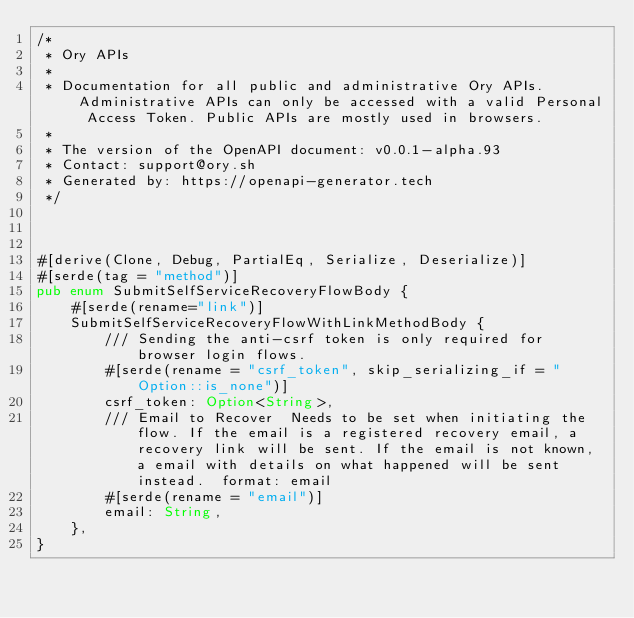Convert code to text. <code><loc_0><loc_0><loc_500><loc_500><_Rust_>/*
 * Ory APIs
 *
 * Documentation for all public and administrative Ory APIs. Administrative APIs can only be accessed with a valid Personal Access Token. Public APIs are mostly used in browsers. 
 *
 * The version of the OpenAPI document: v0.0.1-alpha.93
 * Contact: support@ory.sh
 * Generated by: https://openapi-generator.tech
 */



#[derive(Clone, Debug, PartialEq, Serialize, Deserialize)]
#[serde(tag = "method")]
pub enum SubmitSelfServiceRecoveryFlowBody {
    #[serde(rename="link")]
    SubmitSelfServiceRecoveryFlowWithLinkMethodBody {
        /// Sending the anti-csrf token is only required for browser login flows.
        #[serde(rename = "csrf_token", skip_serializing_if = "Option::is_none")]
        csrf_token: Option<String>,
        /// Email to Recover  Needs to be set when initiating the flow. If the email is a registered recovery email, a recovery link will be sent. If the email is not known, a email with details on what happened will be sent instead.  format: email
        #[serde(rename = "email")]
        email: String,
    },
}




</code> 